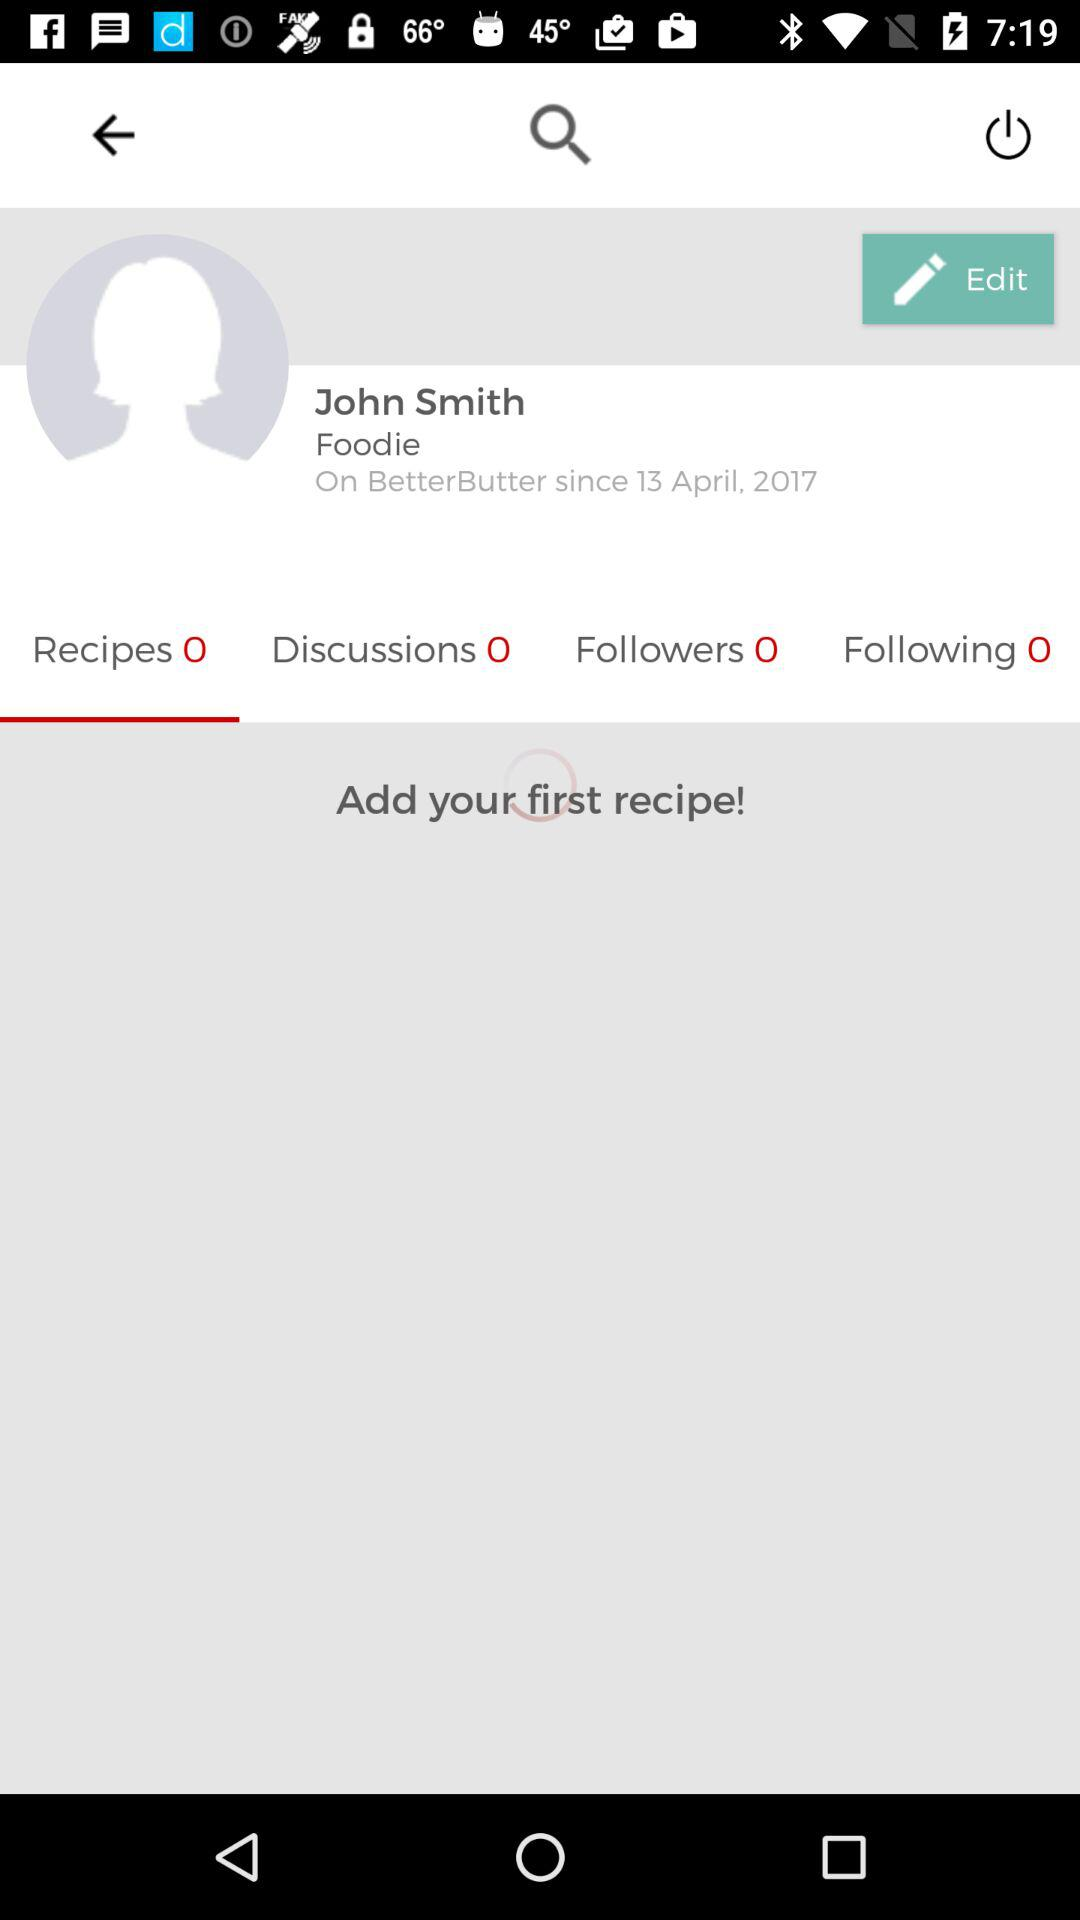What is the name of the user? The name of the user is John Smith. 